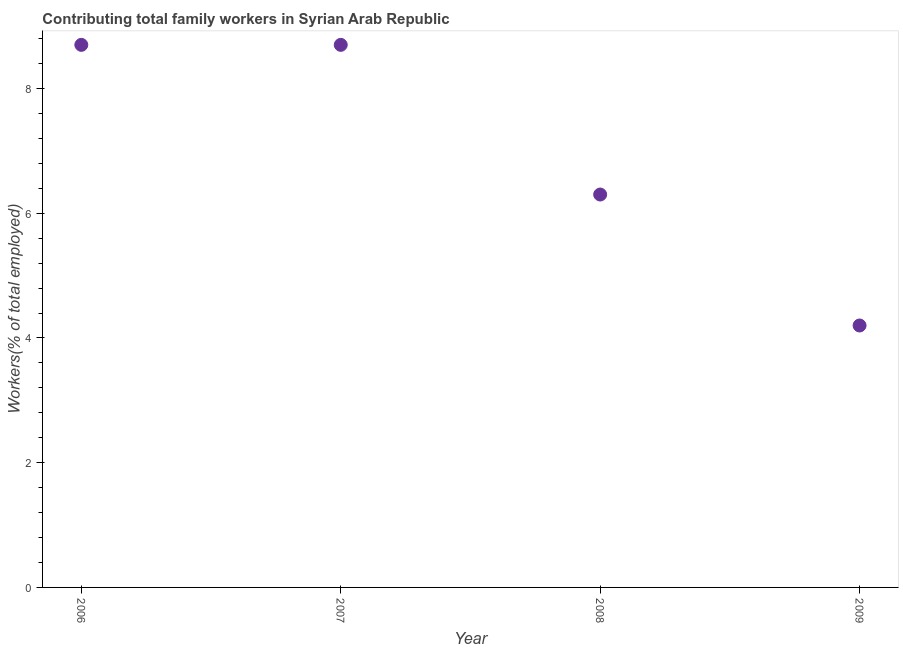What is the contributing family workers in 2006?
Give a very brief answer. 8.7. Across all years, what is the maximum contributing family workers?
Your response must be concise. 8.7. Across all years, what is the minimum contributing family workers?
Your answer should be very brief. 4.2. In which year was the contributing family workers maximum?
Provide a short and direct response. 2006. In which year was the contributing family workers minimum?
Give a very brief answer. 2009. What is the sum of the contributing family workers?
Ensure brevity in your answer.  27.9. What is the difference between the contributing family workers in 2008 and 2009?
Make the answer very short. 2.1. What is the average contributing family workers per year?
Offer a very short reply. 6.97. Do a majority of the years between 2007 and 2008 (inclusive) have contributing family workers greater than 7.6 %?
Ensure brevity in your answer.  No. What is the ratio of the contributing family workers in 2006 to that in 2008?
Provide a succinct answer. 1.38. Is the contributing family workers in 2007 less than that in 2008?
Provide a short and direct response. No. Is the difference between the contributing family workers in 2006 and 2007 greater than the difference between any two years?
Make the answer very short. No. What is the difference between the highest and the second highest contributing family workers?
Provide a succinct answer. 0. Is the sum of the contributing family workers in 2007 and 2008 greater than the maximum contributing family workers across all years?
Provide a succinct answer. Yes. What is the difference between the highest and the lowest contributing family workers?
Your response must be concise. 4.5. In how many years, is the contributing family workers greater than the average contributing family workers taken over all years?
Keep it short and to the point. 2. How many dotlines are there?
Give a very brief answer. 1. What is the difference between two consecutive major ticks on the Y-axis?
Offer a terse response. 2. Are the values on the major ticks of Y-axis written in scientific E-notation?
Provide a short and direct response. No. Does the graph contain grids?
Provide a succinct answer. No. What is the title of the graph?
Give a very brief answer. Contributing total family workers in Syrian Arab Republic. What is the label or title of the X-axis?
Offer a very short reply. Year. What is the label or title of the Y-axis?
Provide a short and direct response. Workers(% of total employed). What is the Workers(% of total employed) in 2006?
Your answer should be compact. 8.7. What is the Workers(% of total employed) in 2007?
Make the answer very short. 8.7. What is the Workers(% of total employed) in 2008?
Your answer should be very brief. 6.3. What is the Workers(% of total employed) in 2009?
Offer a terse response. 4.2. What is the difference between the Workers(% of total employed) in 2006 and 2009?
Give a very brief answer. 4.5. What is the difference between the Workers(% of total employed) in 2007 and 2009?
Offer a very short reply. 4.5. What is the difference between the Workers(% of total employed) in 2008 and 2009?
Your answer should be compact. 2.1. What is the ratio of the Workers(% of total employed) in 2006 to that in 2008?
Keep it short and to the point. 1.38. What is the ratio of the Workers(% of total employed) in 2006 to that in 2009?
Your response must be concise. 2.07. What is the ratio of the Workers(% of total employed) in 2007 to that in 2008?
Your answer should be very brief. 1.38. What is the ratio of the Workers(% of total employed) in 2007 to that in 2009?
Offer a terse response. 2.07. 